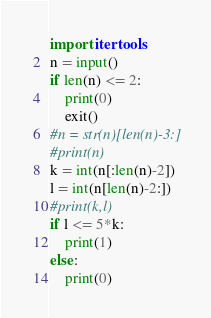<code> <loc_0><loc_0><loc_500><loc_500><_Python_>import itertools
n = input()
if len(n) <= 2:
    print(0)
    exit()
#n = str(n)[len(n)-3:]
#print(n)
k = int(n[:len(n)-2])
l = int(n[len(n)-2:])
#print(k,l)
if l <= 5*k:
    print(1)
else:
    print(0)
</code> 